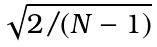<formula> <loc_0><loc_0><loc_500><loc_500>\sqrt { 2 / ( N - 1 ) }</formula> 